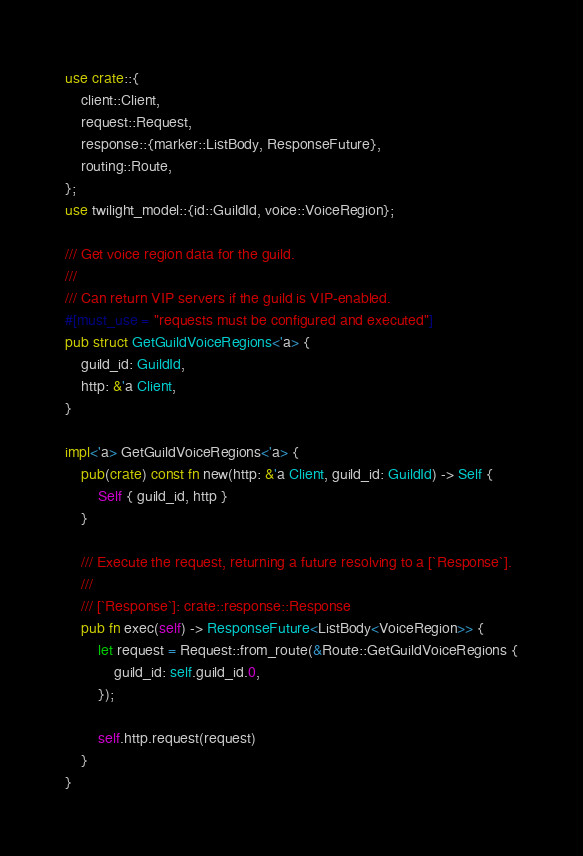<code> <loc_0><loc_0><loc_500><loc_500><_Rust_>use crate::{
    client::Client,
    request::Request,
    response::{marker::ListBody, ResponseFuture},
    routing::Route,
};
use twilight_model::{id::GuildId, voice::VoiceRegion};

/// Get voice region data for the guild.
///
/// Can return VIP servers if the guild is VIP-enabled.
#[must_use = "requests must be configured and executed"]
pub struct GetGuildVoiceRegions<'a> {
    guild_id: GuildId,
    http: &'a Client,
}

impl<'a> GetGuildVoiceRegions<'a> {
    pub(crate) const fn new(http: &'a Client, guild_id: GuildId) -> Self {
        Self { guild_id, http }
    }

    /// Execute the request, returning a future resolving to a [`Response`].
    ///
    /// [`Response`]: crate::response::Response
    pub fn exec(self) -> ResponseFuture<ListBody<VoiceRegion>> {
        let request = Request::from_route(&Route::GetGuildVoiceRegions {
            guild_id: self.guild_id.0,
        });

        self.http.request(request)
    }
}
</code> 